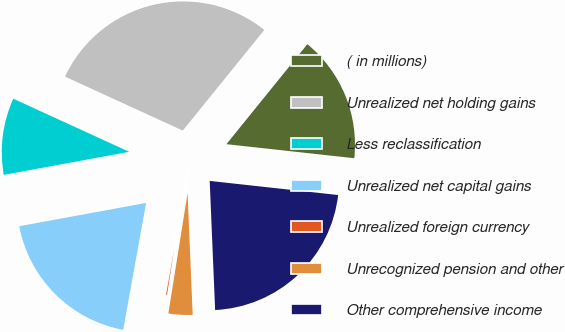Convert chart. <chart><loc_0><loc_0><loc_500><loc_500><pie_chart><fcel>( in millions)<fcel>Unrealized net holding gains<fcel>Less reclassification<fcel>Unrealized net capital gains<fcel>Unrealized foreign currency<fcel>Unrecognized pension and other<fcel>Other comprehensive income<nl><fcel>15.91%<fcel>29.0%<fcel>9.73%<fcel>19.27%<fcel>0.32%<fcel>3.19%<fcel>22.59%<nl></chart> 